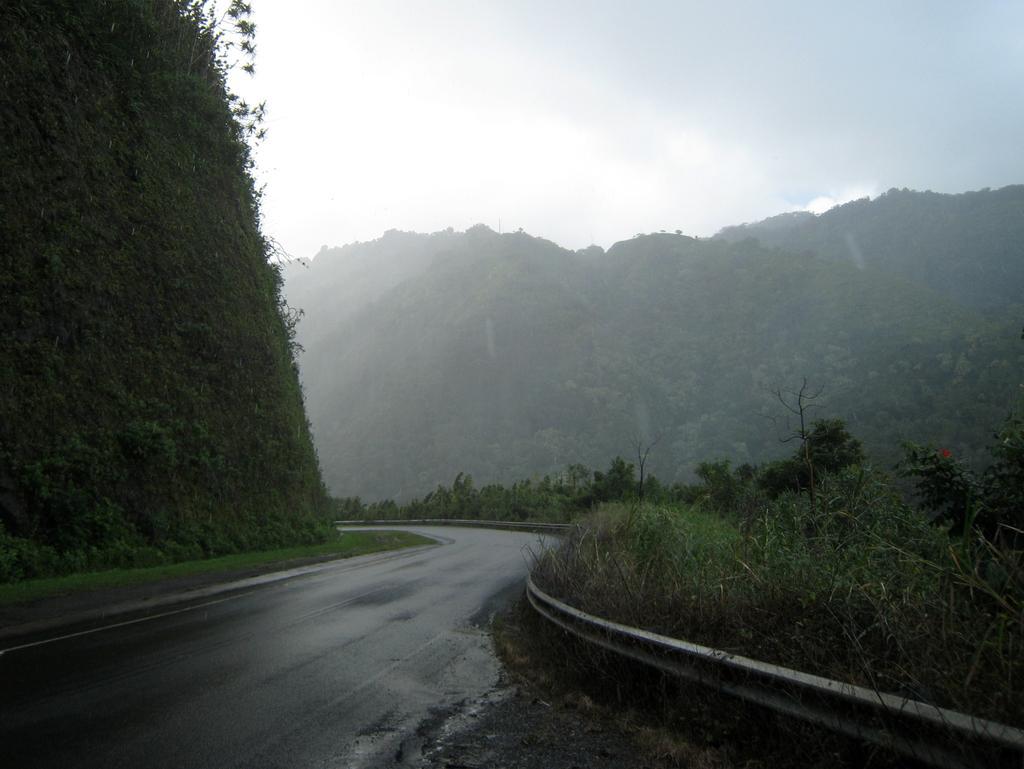Describe this image in one or two sentences. In this image we can see a road and a barrier. Behind the road we can see mountains and on the mountains we can see a group of plants. On the right side, we can see few trees. At the top we can see the sky. 